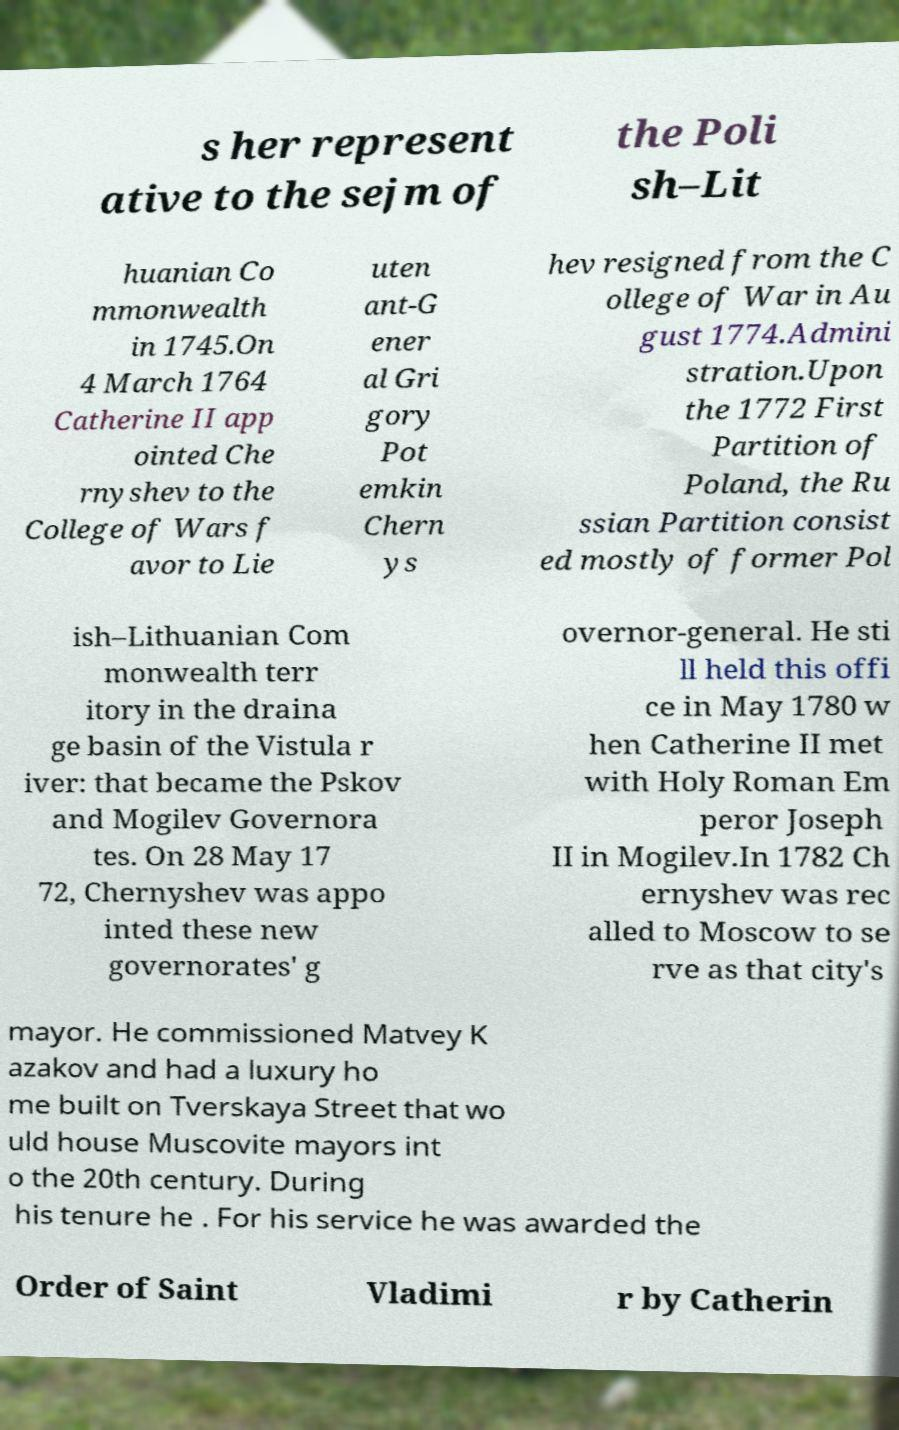What messages or text are displayed in this image? I need them in a readable, typed format. s her represent ative to the sejm of the Poli sh–Lit huanian Co mmonwealth in 1745.On 4 March 1764 Catherine II app ointed Che rnyshev to the College of Wars f avor to Lie uten ant-G ener al Gri gory Pot emkin Chern ys hev resigned from the C ollege of War in Au gust 1774.Admini stration.Upon the 1772 First Partition of Poland, the Ru ssian Partition consist ed mostly of former Pol ish–Lithuanian Com monwealth terr itory in the draina ge basin of the Vistula r iver: that became the Pskov and Mogilev Governora tes. On 28 May 17 72, Chernyshev was appo inted these new governorates' g overnor-general. He sti ll held this offi ce in May 1780 w hen Catherine II met with Holy Roman Em peror Joseph II in Mogilev.In 1782 Ch ernyshev was rec alled to Moscow to se rve as that city's mayor. He commissioned Matvey K azakov and had a luxury ho me built on Tverskaya Street that wo uld house Muscovite mayors int o the 20th century. During his tenure he . For his service he was awarded the Order of Saint Vladimi r by Catherin 